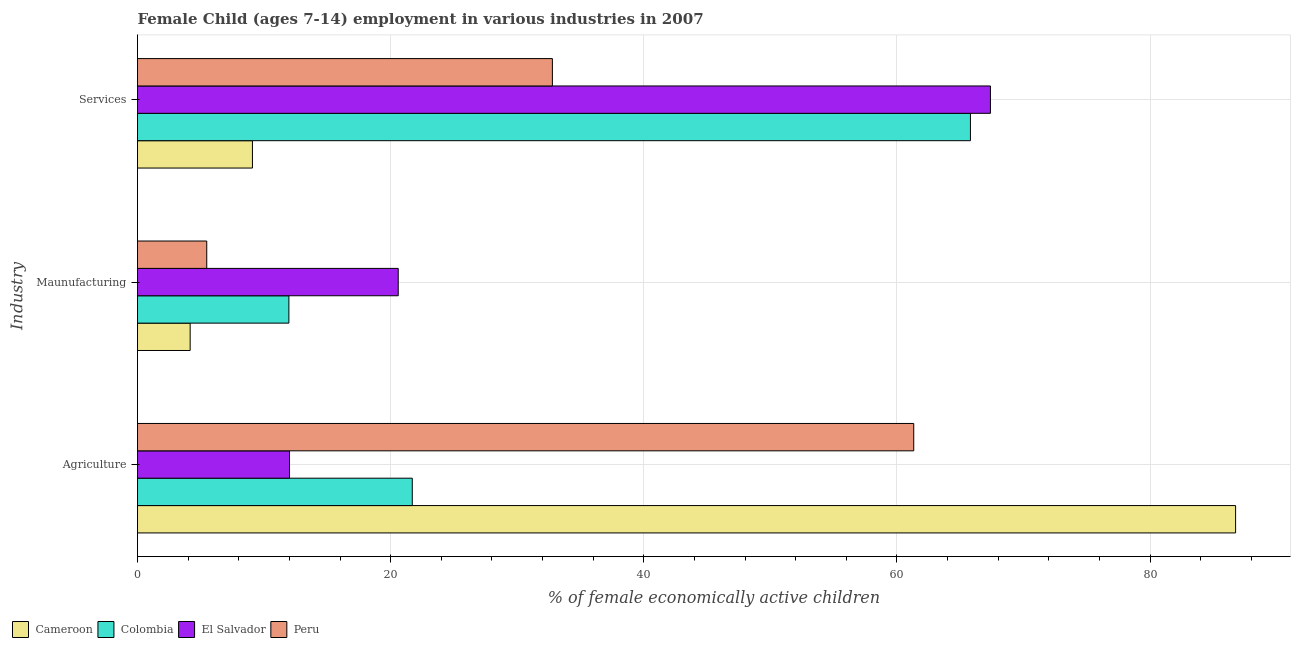How many different coloured bars are there?
Ensure brevity in your answer.  4. How many bars are there on the 3rd tick from the top?
Your response must be concise. 4. What is the label of the 3rd group of bars from the top?
Your answer should be compact. Agriculture. What is the percentage of economically active children in services in Peru?
Ensure brevity in your answer.  32.78. Across all countries, what is the maximum percentage of economically active children in manufacturing?
Provide a succinct answer. 20.6. Across all countries, what is the minimum percentage of economically active children in agriculture?
Give a very brief answer. 12.01. In which country was the percentage of economically active children in agriculture maximum?
Your answer should be compact. Cameroon. In which country was the percentage of economically active children in services minimum?
Your answer should be very brief. Cameroon. What is the total percentage of economically active children in agriculture in the graph?
Provide a succinct answer. 181.81. What is the difference between the percentage of economically active children in manufacturing in Peru and that in Cameroon?
Keep it short and to the point. 1.31. What is the difference between the percentage of economically active children in manufacturing in Peru and the percentage of economically active children in services in Colombia?
Ensure brevity in your answer.  -60.34. What is the average percentage of economically active children in manufacturing per country?
Provide a succinct answer. 10.55. What is the difference between the percentage of economically active children in manufacturing and percentage of economically active children in agriculture in Peru?
Your answer should be compact. -55.86. What is the ratio of the percentage of economically active children in services in Colombia to that in El Salvador?
Offer a very short reply. 0.98. Is the percentage of economically active children in services in El Salvador less than that in Colombia?
Provide a succinct answer. No. Is the difference between the percentage of economically active children in services in Peru and Cameroon greater than the difference between the percentage of economically active children in manufacturing in Peru and Cameroon?
Keep it short and to the point. Yes. What is the difference between the highest and the second highest percentage of economically active children in manufacturing?
Keep it short and to the point. 8.64. What is the difference between the highest and the lowest percentage of economically active children in manufacturing?
Your answer should be compact. 16.44. In how many countries, is the percentage of economically active children in agriculture greater than the average percentage of economically active children in agriculture taken over all countries?
Offer a terse response. 2. What does the 4th bar from the top in Services represents?
Offer a terse response. Cameroon. How many bars are there?
Offer a very short reply. 12. Are the values on the major ticks of X-axis written in scientific E-notation?
Your response must be concise. No. How many legend labels are there?
Give a very brief answer. 4. What is the title of the graph?
Offer a very short reply. Female Child (ages 7-14) employment in various industries in 2007. Does "East Asia (developing only)" appear as one of the legend labels in the graph?
Your answer should be compact. No. What is the label or title of the X-axis?
Offer a very short reply. % of female economically active children. What is the label or title of the Y-axis?
Keep it short and to the point. Industry. What is the % of female economically active children in Cameroon in Agriculture?
Provide a succinct answer. 86.76. What is the % of female economically active children of Colombia in Agriculture?
Your answer should be compact. 21.71. What is the % of female economically active children of El Salvador in Agriculture?
Provide a short and direct response. 12.01. What is the % of female economically active children in Peru in Agriculture?
Keep it short and to the point. 61.33. What is the % of female economically active children of Cameroon in Maunufacturing?
Provide a short and direct response. 4.16. What is the % of female economically active children in Colombia in Maunufacturing?
Offer a very short reply. 11.96. What is the % of female economically active children in El Salvador in Maunufacturing?
Ensure brevity in your answer.  20.6. What is the % of female economically active children of Peru in Maunufacturing?
Keep it short and to the point. 5.47. What is the % of female economically active children of Cameroon in Services?
Ensure brevity in your answer.  9.08. What is the % of female economically active children in Colombia in Services?
Ensure brevity in your answer.  65.81. What is the % of female economically active children in El Salvador in Services?
Ensure brevity in your answer.  67.39. What is the % of female economically active children in Peru in Services?
Your answer should be very brief. 32.78. Across all Industry, what is the maximum % of female economically active children of Cameroon?
Offer a terse response. 86.76. Across all Industry, what is the maximum % of female economically active children of Colombia?
Offer a terse response. 65.81. Across all Industry, what is the maximum % of female economically active children in El Salvador?
Provide a succinct answer. 67.39. Across all Industry, what is the maximum % of female economically active children of Peru?
Your answer should be very brief. 61.33. Across all Industry, what is the minimum % of female economically active children in Cameroon?
Provide a succinct answer. 4.16. Across all Industry, what is the minimum % of female economically active children in Colombia?
Make the answer very short. 11.96. Across all Industry, what is the minimum % of female economically active children in El Salvador?
Offer a very short reply. 12.01. Across all Industry, what is the minimum % of female economically active children of Peru?
Your response must be concise. 5.47. What is the total % of female economically active children in Colombia in the graph?
Make the answer very short. 99.48. What is the total % of female economically active children in El Salvador in the graph?
Ensure brevity in your answer.  100. What is the total % of female economically active children of Peru in the graph?
Ensure brevity in your answer.  99.58. What is the difference between the % of female economically active children in Cameroon in Agriculture and that in Maunufacturing?
Provide a short and direct response. 82.6. What is the difference between the % of female economically active children of Colombia in Agriculture and that in Maunufacturing?
Your response must be concise. 9.75. What is the difference between the % of female economically active children in El Salvador in Agriculture and that in Maunufacturing?
Offer a terse response. -8.59. What is the difference between the % of female economically active children in Peru in Agriculture and that in Maunufacturing?
Provide a succinct answer. 55.86. What is the difference between the % of female economically active children of Cameroon in Agriculture and that in Services?
Make the answer very short. 77.68. What is the difference between the % of female economically active children of Colombia in Agriculture and that in Services?
Provide a short and direct response. -44.1. What is the difference between the % of female economically active children in El Salvador in Agriculture and that in Services?
Your response must be concise. -55.38. What is the difference between the % of female economically active children in Peru in Agriculture and that in Services?
Offer a very short reply. 28.55. What is the difference between the % of female economically active children in Cameroon in Maunufacturing and that in Services?
Offer a very short reply. -4.92. What is the difference between the % of female economically active children in Colombia in Maunufacturing and that in Services?
Ensure brevity in your answer.  -53.85. What is the difference between the % of female economically active children in El Salvador in Maunufacturing and that in Services?
Offer a very short reply. -46.79. What is the difference between the % of female economically active children of Peru in Maunufacturing and that in Services?
Ensure brevity in your answer.  -27.31. What is the difference between the % of female economically active children of Cameroon in Agriculture and the % of female economically active children of Colombia in Maunufacturing?
Your answer should be compact. 74.8. What is the difference between the % of female economically active children of Cameroon in Agriculture and the % of female economically active children of El Salvador in Maunufacturing?
Provide a succinct answer. 66.16. What is the difference between the % of female economically active children in Cameroon in Agriculture and the % of female economically active children in Peru in Maunufacturing?
Ensure brevity in your answer.  81.29. What is the difference between the % of female economically active children of Colombia in Agriculture and the % of female economically active children of El Salvador in Maunufacturing?
Make the answer very short. 1.11. What is the difference between the % of female economically active children in Colombia in Agriculture and the % of female economically active children in Peru in Maunufacturing?
Your response must be concise. 16.24. What is the difference between the % of female economically active children in El Salvador in Agriculture and the % of female economically active children in Peru in Maunufacturing?
Provide a succinct answer. 6.54. What is the difference between the % of female economically active children in Cameroon in Agriculture and the % of female economically active children in Colombia in Services?
Make the answer very short. 20.95. What is the difference between the % of female economically active children of Cameroon in Agriculture and the % of female economically active children of El Salvador in Services?
Make the answer very short. 19.37. What is the difference between the % of female economically active children in Cameroon in Agriculture and the % of female economically active children in Peru in Services?
Give a very brief answer. 53.98. What is the difference between the % of female economically active children in Colombia in Agriculture and the % of female economically active children in El Salvador in Services?
Your response must be concise. -45.68. What is the difference between the % of female economically active children of Colombia in Agriculture and the % of female economically active children of Peru in Services?
Keep it short and to the point. -11.07. What is the difference between the % of female economically active children in El Salvador in Agriculture and the % of female economically active children in Peru in Services?
Ensure brevity in your answer.  -20.77. What is the difference between the % of female economically active children of Cameroon in Maunufacturing and the % of female economically active children of Colombia in Services?
Offer a terse response. -61.65. What is the difference between the % of female economically active children of Cameroon in Maunufacturing and the % of female economically active children of El Salvador in Services?
Ensure brevity in your answer.  -63.23. What is the difference between the % of female economically active children of Cameroon in Maunufacturing and the % of female economically active children of Peru in Services?
Offer a very short reply. -28.62. What is the difference between the % of female economically active children in Colombia in Maunufacturing and the % of female economically active children in El Salvador in Services?
Offer a terse response. -55.43. What is the difference between the % of female economically active children in Colombia in Maunufacturing and the % of female economically active children in Peru in Services?
Ensure brevity in your answer.  -20.82. What is the difference between the % of female economically active children in El Salvador in Maunufacturing and the % of female economically active children in Peru in Services?
Make the answer very short. -12.18. What is the average % of female economically active children of Cameroon per Industry?
Offer a very short reply. 33.33. What is the average % of female economically active children of Colombia per Industry?
Your answer should be very brief. 33.16. What is the average % of female economically active children of El Salvador per Industry?
Offer a very short reply. 33.33. What is the average % of female economically active children in Peru per Industry?
Provide a short and direct response. 33.19. What is the difference between the % of female economically active children in Cameroon and % of female economically active children in Colombia in Agriculture?
Your response must be concise. 65.05. What is the difference between the % of female economically active children of Cameroon and % of female economically active children of El Salvador in Agriculture?
Offer a very short reply. 74.75. What is the difference between the % of female economically active children in Cameroon and % of female economically active children in Peru in Agriculture?
Provide a short and direct response. 25.43. What is the difference between the % of female economically active children in Colombia and % of female economically active children in El Salvador in Agriculture?
Give a very brief answer. 9.7. What is the difference between the % of female economically active children of Colombia and % of female economically active children of Peru in Agriculture?
Provide a succinct answer. -39.62. What is the difference between the % of female economically active children in El Salvador and % of female economically active children in Peru in Agriculture?
Keep it short and to the point. -49.32. What is the difference between the % of female economically active children in Cameroon and % of female economically active children in El Salvador in Maunufacturing?
Provide a succinct answer. -16.44. What is the difference between the % of female economically active children in Cameroon and % of female economically active children in Peru in Maunufacturing?
Offer a terse response. -1.31. What is the difference between the % of female economically active children of Colombia and % of female economically active children of El Salvador in Maunufacturing?
Keep it short and to the point. -8.64. What is the difference between the % of female economically active children of Colombia and % of female economically active children of Peru in Maunufacturing?
Your response must be concise. 6.49. What is the difference between the % of female economically active children of El Salvador and % of female economically active children of Peru in Maunufacturing?
Ensure brevity in your answer.  15.13. What is the difference between the % of female economically active children in Cameroon and % of female economically active children in Colombia in Services?
Provide a short and direct response. -56.73. What is the difference between the % of female economically active children in Cameroon and % of female economically active children in El Salvador in Services?
Your answer should be compact. -58.31. What is the difference between the % of female economically active children of Cameroon and % of female economically active children of Peru in Services?
Offer a very short reply. -23.7. What is the difference between the % of female economically active children in Colombia and % of female economically active children in El Salvador in Services?
Your answer should be very brief. -1.58. What is the difference between the % of female economically active children of Colombia and % of female economically active children of Peru in Services?
Ensure brevity in your answer.  33.03. What is the difference between the % of female economically active children of El Salvador and % of female economically active children of Peru in Services?
Offer a terse response. 34.61. What is the ratio of the % of female economically active children of Cameroon in Agriculture to that in Maunufacturing?
Your answer should be compact. 20.86. What is the ratio of the % of female economically active children in Colombia in Agriculture to that in Maunufacturing?
Offer a terse response. 1.82. What is the ratio of the % of female economically active children in El Salvador in Agriculture to that in Maunufacturing?
Make the answer very short. 0.58. What is the ratio of the % of female economically active children in Peru in Agriculture to that in Maunufacturing?
Give a very brief answer. 11.21. What is the ratio of the % of female economically active children of Cameroon in Agriculture to that in Services?
Keep it short and to the point. 9.56. What is the ratio of the % of female economically active children in Colombia in Agriculture to that in Services?
Offer a terse response. 0.33. What is the ratio of the % of female economically active children in El Salvador in Agriculture to that in Services?
Provide a succinct answer. 0.18. What is the ratio of the % of female economically active children of Peru in Agriculture to that in Services?
Your answer should be compact. 1.87. What is the ratio of the % of female economically active children in Cameroon in Maunufacturing to that in Services?
Provide a succinct answer. 0.46. What is the ratio of the % of female economically active children of Colombia in Maunufacturing to that in Services?
Offer a terse response. 0.18. What is the ratio of the % of female economically active children in El Salvador in Maunufacturing to that in Services?
Offer a very short reply. 0.31. What is the ratio of the % of female economically active children in Peru in Maunufacturing to that in Services?
Your answer should be very brief. 0.17. What is the difference between the highest and the second highest % of female economically active children of Cameroon?
Offer a very short reply. 77.68. What is the difference between the highest and the second highest % of female economically active children of Colombia?
Make the answer very short. 44.1. What is the difference between the highest and the second highest % of female economically active children of El Salvador?
Ensure brevity in your answer.  46.79. What is the difference between the highest and the second highest % of female economically active children of Peru?
Provide a short and direct response. 28.55. What is the difference between the highest and the lowest % of female economically active children in Cameroon?
Make the answer very short. 82.6. What is the difference between the highest and the lowest % of female economically active children in Colombia?
Keep it short and to the point. 53.85. What is the difference between the highest and the lowest % of female economically active children of El Salvador?
Make the answer very short. 55.38. What is the difference between the highest and the lowest % of female economically active children in Peru?
Your answer should be compact. 55.86. 